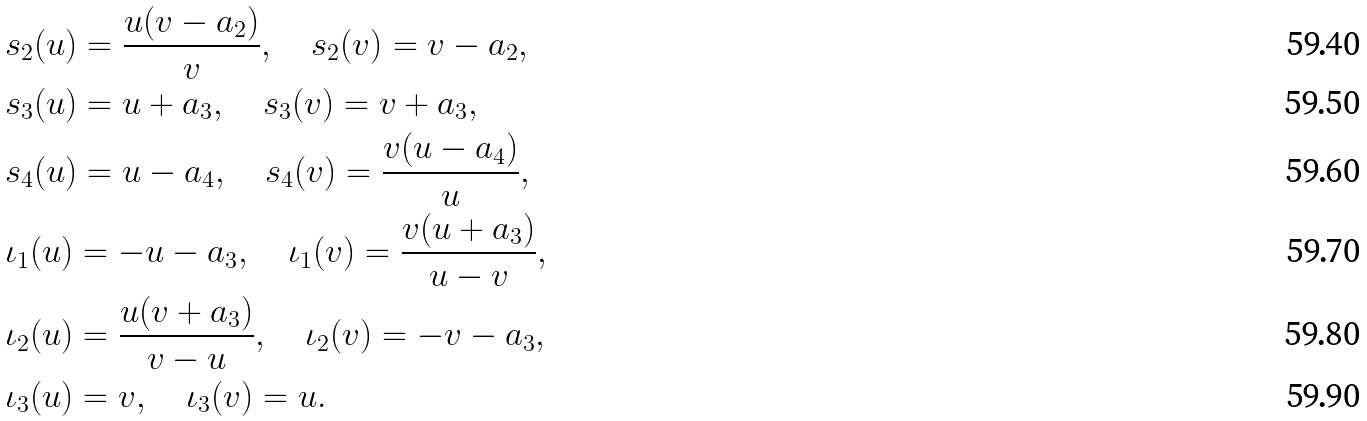<formula> <loc_0><loc_0><loc_500><loc_500>& s _ { 2 } ( u ) = \frac { u ( v - a _ { 2 } ) } { v } , \quad s _ { 2 } ( v ) = v - a _ { 2 } , \\ & s _ { 3 } ( u ) = u + a _ { 3 } , \quad s _ { 3 } ( v ) = v + a _ { 3 } , \\ & s _ { 4 } ( u ) = u - a _ { 4 } , \quad s _ { 4 } ( v ) = \frac { v ( u - a _ { 4 } ) } { u } , \\ & \iota _ { 1 } ( u ) = - u - a _ { 3 } , \quad \iota _ { 1 } ( v ) = \frac { v ( u + a _ { 3 } ) } { u - v } , \\ & \iota _ { 2 } ( u ) = \frac { u ( v + a _ { 3 } ) } { v - u } , \quad \iota _ { 2 } ( v ) = - v - a _ { 3 } , \\ & \iota _ { 3 } ( u ) = v , \quad \iota _ { 3 } ( v ) = u .</formula> 